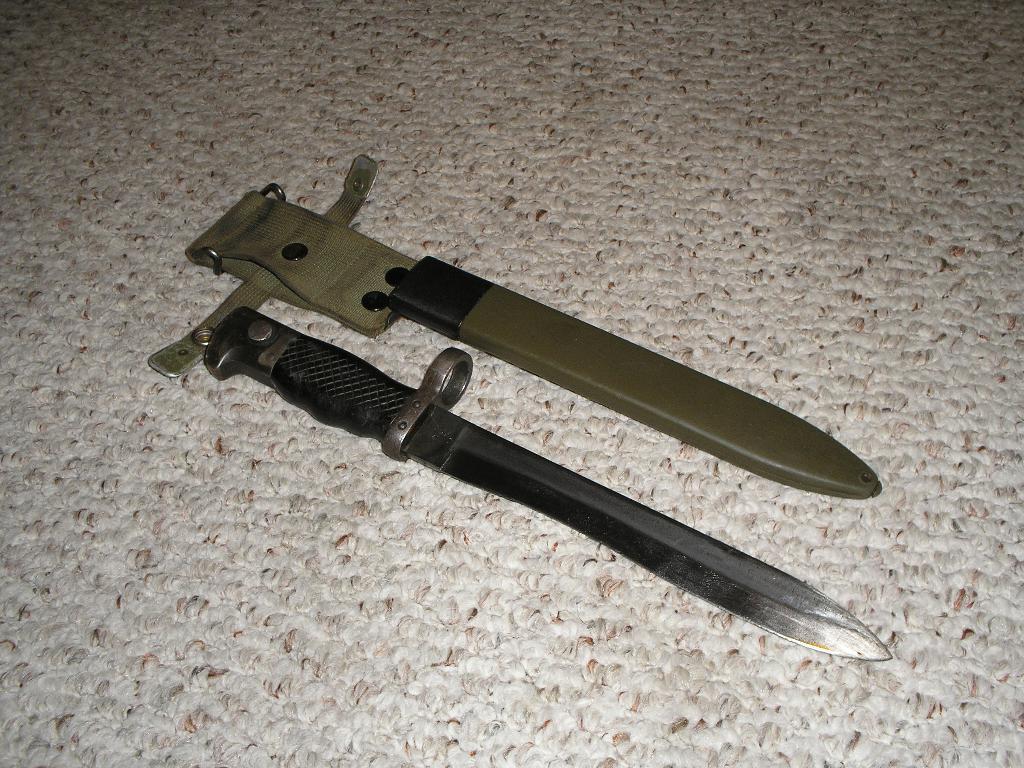Describe this image in one or two sentences. In this image we can see two objects on the floor. 